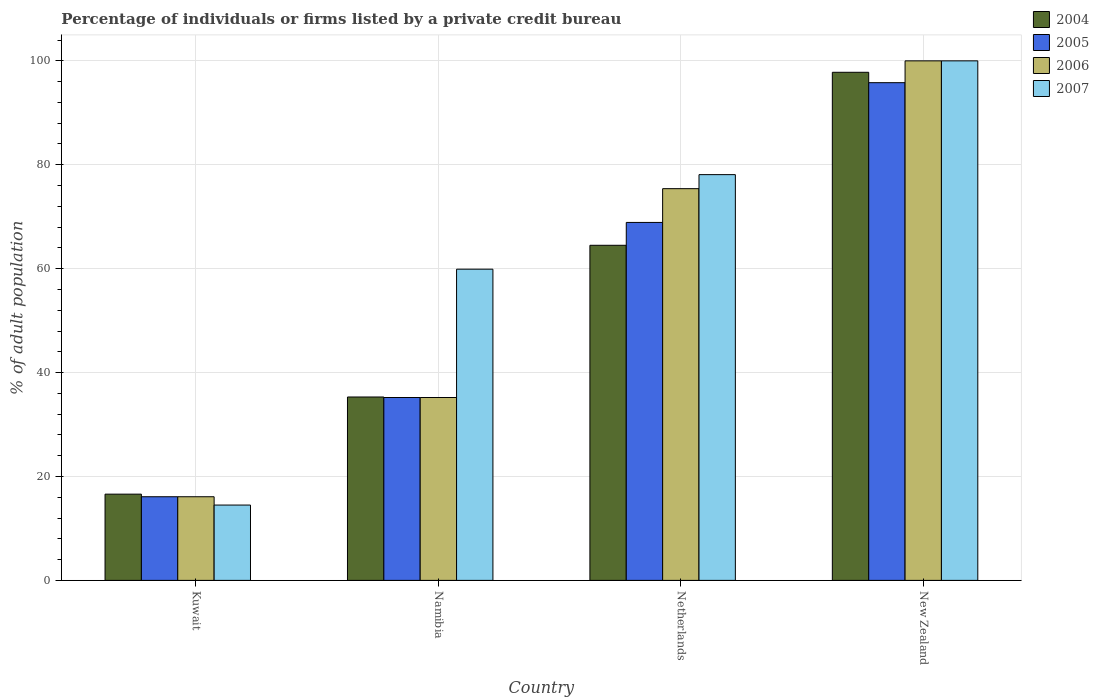How many different coloured bars are there?
Offer a very short reply. 4. How many groups of bars are there?
Provide a succinct answer. 4. How many bars are there on the 2nd tick from the left?
Make the answer very short. 4. How many bars are there on the 2nd tick from the right?
Keep it short and to the point. 4. What is the percentage of population listed by a private credit bureau in 2005 in Namibia?
Make the answer very short. 35.2. In which country was the percentage of population listed by a private credit bureau in 2007 maximum?
Keep it short and to the point. New Zealand. In which country was the percentage of population listed by a private credit bureau in 2006 minimum?
Provide a short and direct response. Kuwait. What is the total percentage of population listed by a private credit bureau in 2004 in the graph?
Give a very brief answer. 214.2. What is the difference between the percentage of population listed by a private credit bureau in 2006 in Kuwait and that in New Zealand?
Provide a succinct answer. -83.9. What is the difference between the percentage of population listed by a private credit bureau in 2005 in Kuwait and the percentage of population listed by a private credit bureau in 2006 in New Zealand?
Provide a succinct answer. -83.9. What is the average percentage of population listed by a private credit bureau in 2004 per country?
Make the answer very short. 53.55. What is the difference between the percentage of population listed by a private credit bureau of/in 2006 and percentage of population listed by a private credit bureau of/in 2004 in Netherlands?
Make the answer very short. 10.9. What is the ratio of the percentage of population listed by a private credit bureau in 2004 in Kuwait to that in New Zealand?
Keep it short and to the point. 0.17. Is the difference between the percentage of population listed by a private credit bureau in 2006 in Kuwait and Namibia greater than the difference between the percentage of population listed by a private credit bureau in 2004 in Kuwait and Namibia?
Offer a very short reply. No. What is the difference between the highest and the second highest percentage of population listed by a private credit bureau in 2005?
Offer a terse response. -33.7. What is the difference between the highest and the lowest percentage of population listed by a private credit bureau in 2004?
Provide a short and direct response. 81.2. In how many countries, is the percentage of population listed by a private credit bureau in 2005 greater than the average percentage of population listed by a private credit bureau in 2005 taken over all countries?
Your answer should be very brief. 2. Is it the case that in every country, the sum of the percentage of population listed by a private credit bureau in 2007 and percentage of population listed by a private credit bureau in 2005 is greater than the sum of percentage of population listed by a private credit bureau in 2004 and percentage of population listed by a private credit bureau in 2006?
Your answer should be compact. No. What does the 4th bar from the left in Kuwait represents?
Keep it short and to the point. 2007. What does the 4th bar from the right in New Zealand represents?
Your answer should be very brief. 2004. How many bars are there?
Offer a terse response. 16. Are all the bars in the graph horizontal?
Ensure brevity in your answer.  No. What is the difference between two consecutive major ticks on the Y-axis?
Keep it short and to the point. 20. Where does the legend appear in the graph?
Offer a very short reply. Top right. How many legend labels are there?
Offer a terse response. 4. What is the title of the graph?
Provide a short and direct response. Percentage of individuals or firms listed by a private credit bureau. What is the label or title of the Y-axis?
Provide a succinct answer. % of adult population. What is the % of adult population of 2005 in Kuwait?
Your answer should be very brief. 16.1. What is the % of adult population in 2006 in Kuwait?
Make the answer very short. 16.1. What is the % of adult population in 2007 in Kuwait?
Provide a succinct answer. 14.5. What is the % of adult population in 2004 in Namibia?
Your answer should be very brief. 35.3. What is the % of adult population in 2005 in Namibia?
Keep it short and to the point. 35.2. What is the % of adult population of 2006 in Namibia?
Provide a short and direct response. 35.2. What is the % of adult population in 2007 in Namibia?
Give a very brief answer. 59.9. What is the % of adult population in 2004 in Netherlands?
Provide a succinct answer. 64.5. What is the % of adult population in 2005 in Netherlands?
Your answer should be very brief. 68.9. What is the % of adult population of 2006 in Netherlands?
Offer a terse response. 75.4. What is the % of adult population of 2007 in Netherlands?
Your response must be concise. 78.1. What is the % of adult population in 2004 in New Zealand?
Provide a succinct answer. 97.8. What is the % of adult population of 2005 in New Zealand?
Provide a succinct answer. 95.8. What is the % of adult population of 2006 in New Zealand?
Your answer should be very brief. 100. Across all countries, what is the maximum % of adult population in 2004?
Provide a short and direct response. 97.8. Across all countries, what is the maximum % of adult population of 2005?
Offer a terse response. 95.8. Across all countries, what is the maximum % of adult population in 2006?
Provide a succinct answer. 100. Across all countries, what is the minimum % of adult population of 2004?
Your answer should be very brief. 16.6. Across all countries, what is the minimum % of adult population of 2006?
Make the answer very short. 16.1. Across all countries, what is the minimum % of adult population of 2007?
Provide a succinct answer. 14.5. What is the total % of adult population in 2004 in the graph?
Keep it short and to the point. 214.2. What is the total % of adult population of 2005 in the graph?
Your answer should be compact. 216. What is the total % of adult population of 2006 in the graph?
Provide a short and direct response. 226.7. What is the total % of adult population of 2007 in the graph?
Your response must be concise. 252.5. What is the difference between the % of adult population of 2004 in Kuwait and that in Namibia?
Provide a short and direct response. -18.7. What is the difference between the % of adult population of 2005 in Kuwait and that in Namibia?
Keep it short and to the point. -19.1. What is the difference between the % of adult population of 2006 in Kuwait and that in Namibia?
Ensure brevity in your answer.  -19.1. What is the difference between the % of adult population in 2007 in Kuwait and that in Namibia?
Your answer should be very brief. -45.4. What is the difference between the % of adult population in 2004 in Kuwait and that in Netherlands?
Your answer should be compact. -47.9. What is the difference between the % of adult population of 2005 in Kuwait and that in Netherlands?
Offer a very short reply. -52.8. What is the difference between the % of adult population of 2006 in Kuwait and that in Netherlands?
Keep it short and to the point. -59.3. What is the difference between the % of adult population of 2007 in Kuwait and that in Netherlands?
Your answer should be very brief. -63.6. What is the difference between the % of adult population of 2004 in Kuwait and that in New Zealand?
Offer a very short reply. -81.2. What is the difference between the % of adult population of 2005 in Kuwait and that in New Zealand?
Offer a terse response. -79.7. What is the difference between the % of adult population of 2006 in Kuwait and that in New Zealand?
Offer a terse response. -83.9. What is the difference between the % of adult population in 2007 in Kuwait and that in New Zealand?
Offer a very short reply. -85.5. What is the difference between the % of adult population in 2004 in Namibia and that in Netherlands?
Ensure brevity in your answer.  -29.2. What is the difference between the % of adult population of 2005 in Namibia and that in Netherlands?
Provide a succinct answer. -33.7. What is the difference between the % of adult population in 2006 in Namibia and that in Netherlands?
Offer a very short reply. -40.2. What is the difference between the % of adult population in 2007 in Namibia and that in Netherlands?
Provide a succinct answer. -18.2. What is the difference between the % of adult population in 2004 in Namibia and that in New Zealand?
Make the answer very short. -62.5. What is the difference between the % of adult population of 2005 in Namibia and that in New Zealand?
Offer a terse response. -60.6. What is the difference between the % of adult population in 2006 in Namibia and that in New Zealand?
Ensure brevity in your answer.  -64.8. What is the difference between the % of adult population of 2007 in Namibia and that in New Zealand?
Make the answer very short. -40.1. What is the difference between the % of adult population of 2004 in Netherlands and that in New Zealand?
Provide a succinct answer. -33.3. What is the difference between the % of adult population of 2005 in Netherlands and that in New Zealand?
Offer a terse response. -26.9. What is the difference between the % of adult population in 2006 in Netherlands and that in New Zealand?
Make the answer very short. -24.6. What is the difference between the % of adult population of 2007 in Netherlands and that in New Zealand?
Your answer should be compact. -21.9. What is the difference between the % of adult population of 2004 in Kuwait and the % of adult population of 2005 in Namibia?
Offer a terse response. -18.6. What is the difference between the % of adult population of 2004 in Kuwait and the % of adult population of 2006 in Namibia?
Your response must be concise. -18.6. What is the difference between the % of adult population in 2004 in Kuwait and the % of adult population in 2007 in Namibia?
Provide a succinct answer. -43.3. What is the difference between the % of adult population in 2005 in Kuwait and the % of adult population in 2006 in Namibia?
Offer a very short reply. -19.1. What is the difference between the % of adult population in 2005 in Kuwait and the % of adult population in 2007 in Namibia?
Offer a very short reply. -43.8. What is the difference between the % of adult population in 2006 in Kuwait and the % of adult population in 2007 in Namibia?
Offer a terse response. -43.8. What is the difference between the % of adult population in 2004 in Kuwait and the % of adult population in 2005 in Netherlands?
Make the answer very short. -52.3. What is the difference between the % of adult population in 2004 in Kuwait and the % of adult population in 2006 in Netherlands?
Ensure brevity in your answer.  -58.8. What is the difference between the % of adult population of 2004 in Kuwait and the % of adult population of 2007 in Netherlands?
Your answer should be very brief. -61.5. What is the difference between the % of adult population of 2005 in Kuwait and the % of adult population of 2006 in Netherlands?
Keep it short and to the point. -59.3. What is the difference between the % of adult population of 2005 in Kuwait and the % of adult population of 2007 in Netherlands?
Make the answer very short. -62. What is the difference between the % of adult population of 2006 in Kuwait and the % of adult population of 2007 in Netherlands?
Your answer should be very brief. -62. What is the difference between the % of adult population of 2004 in Kuwait and the % of adult population of 2005 in New Zealand?
Your answer should be compact. -79.2. What is the difference between the % of adult population in 2004 in Kuwait and the % of adult population in 2006 in New Zealand?
Give a very brief answer. -83.4. What is the difference between the % of adult population of 2004 in Kuwait and the % of adult population of 2007 in New Zealand?
Give a very brief answer. -83.4. What is the difference between the % of adult population of 2005 in Kuwait and the % of adult population of 2006 in New Zealand?
Keep it short and to the point. -83.9. What is the difference between the % of adult population of 2005 in Kuwait and the % of adult population of 2007 in New Zealand?
Ensure brevity in your answer.  -83.9. What is the difference between the % of adult population of 2006 in Kuwait and the % of adult population of 2007 in New Zealand?
Offer a very short reply. -83.9. What is the difference between the % of adult population of 2004 in Namibia and the % of adult population of 2005 in Netherlands?
Make the answer very short. -33.6. What is the difference between the % of adult population in 2004 in Namibia and the % of adult population in 2006 in Netherlands?
Your answer should be very brief. -40.1. What is the difference between the % of adult population of 2004 in Namibia and the % of adult population of 2007 in Netherlands?
Keep it short and to the point. -42.8. What is the difference between the % of adult population of 2005 in Namibia and the % of adult population of 2006 in Netherlands?
Ensure brevity in your answer.  -40.2. What is the difference between the % of adult population in 2005 in Namibia and the % of adult population in 2007 in Netherlands?
Keep it short and to the point. -42.9. What is the difference between the % of adult population of 2006 in Namibia and the % of adult population of 2007 in Netherlands?
Provide a short and direct response. -42.9. What is the difference between the % of adult population in 2004 in Namibia and the % of adult population in 2005 in New Zealand?
Your response must be concise. -60.5. What is the difference between the % of adult population of 2004 in Namibia and the % of adult population of 2006 in New Zealand?
Ensure brevity in your answer.  -64.7. What is the difference between the % of adult population in 2004 in Namibia and the % of adult population in 2007 in New Zealand?
Give a very brief answer. -64.7. What is the difference between the % of adult population in 2005 in Namibia and the % of adult population in 2006 in New Zealand?
Your response must be concise. -64.8. What is the difference between the % of adult population in 2005 in Namibia and the % of adult population in 2007 in New Zealand?
Give a very brief answer. -64.8. What is the difference between the % of adult population in 2006 in Namibia and the % of adult population in 2007 in New Zealand?
Provide a succinct answer. -64.8. What is the difference between the % of adult population of 2004 in Netherlands and the % of adult population of 2005 in New Zealand?
Offer a terse response. -31.3. What is the difference between the % of adult population of 2004 in Netherlands and the % of adult population of 2006 in New Zealand?
Offer a terse response. -35.5. What is the difference between the % of adult population in 2004 in Netherlands and the % of adult population in 2007 in New Zealand?
Offer a very short reply. -35.5. What is the difference between the % of adult population of 2005 in Netherlands and the % of adult population of 2006 in New Zealand?
Give a very brief answer. -31.1. What is the difference between the % of adult population of 2005 in Netherlands and the % of adult population of 2007 in New Zealand?
Make the answer very short. -31.1. What is the difference between the % of adult population of 2006 in Netherlands and the % of adult population of 2007 in New Zealand?
Your answer should be very brief. -24.6. What is the average % of adult population in 2004 per country?
Offer a very short reply. 53.55. What is the average % of adult population in 2006 per country?
Make the answer very short. 56.67. What is the average % of adult population of 2007 per country?
Your answer should be compact. 63.12. What is the difference between the % of adult population of 2004 and % of adult population of 2007 in Kuwait?
Make the answer very short. 2.1. What is the difference between the % of adult population of 2005 and % of adult population of 2006 in Kuwait?
Keep it short and to the point. 0. What is the difference between the % of adult population of 2005 and % of adult population of 2007 in Kuwait?
Give a very brief answer. 1.6. What is the difference between the % of adult population in 2004 and % of adult population in 2007 in Namibia?
Keep it short and to the point. -24.6. What is the difference between the % of adult population of 2005 and % of adult population of 2007 in Namibia?
Offer a very short reply. -24.7. What is the difference between the % of adult population of 2006 and % of adult population of 2007 in Namibia?
Provide a succinct answer. -24.7. What is the difference between the % of adult population in 2004 and % of adult population in 2005 in Netherlands?
Keep it short and to the point. -4.4. What is the difference between the % of adult population of 2004 and % of adult population of 2006 in Netherlands?
Offer a very short reply. -10.9. What is the difference between the % of adult population of 2004 and % of adult population of 2007 in Netherlands?
Keep it short and to the point. -13.6. What is the difference between the % of adult population in 2004 and % of adult population in 2006 in New Zealand?
Keep it short and to the point. -2.2. What is the difference between the % of adult population in 2004 and % of adult population in 2007 in New Zealand?
Provide a succinct answer. -2.2. What is the difference between the % of adult population of 2005 and % of adult population of 2007 in New Zealand?
Provide a succinct answer. -4.2. What is the ratio of the % of adult population in 2004 in Kuwait to that in Namibia?
Keep it short and to the point. 0.47. What is the ratio of the % of adult population of 2005 in Kuwait to that in Namibia?
Your answer should be compact. 0.46. What is the ratio of the % of adult population of 2006 in Kuwait to that in Namibia?
Give a very brief answer. 0.46. What is the ratio of the % of adult population in 2007 in Kuwait to that in Namibia?
Your answer should be very brief. 0.24. What is the ratio of the % of adult population in 2004 in Kuwait to that in Netherlands?
Provide a short and direct response. 0.26. What is the ratio of the % of adult population in 2005 in Kuwait to that in Netherlands?
Your response must be concise. 0.23. What is the ratio of the % of adult population of 2006 in Kuwait to that in Netherlands?
Make the answer very short. 0.21. What is the ratio of the % of adult population in 2007 in Kuwait to that in Netherlands?
Your answer should be compact. 0.19. What is the ratio of the % of adult population in 2004 in Kuwait to that in New Zealand?
Offer a terse response. 0.17. What is the ratio of the % of adult population of 2005 in Kuwait to that in New Zealand?
Your answer should be very brief. 0.17. What is the ratio of the % of adult population of 2006 in Kuwait to that in New Zealand?
Your response must be concise. 0.16. What is the ratio of the % of adult population in 2007 in Kuwait to that in New Zealand?
Give a very brief answer. 0.14. What is the ratio of the % of adult population in 2004 in Namibia to that in Netherlands?
Provide a succinct answer. 0.55. What is the ratio of the % of adult population in 2005 in Namibia to that in Netherlands?
Your answer should be compact. 0.51. What is the ratio of the % of adult population of 2006 in Namibia to that in Netherlands?
Keep it short and to the point. 0.47. What is the ratio of the % of adult population in 2007 in Namibia to that in Netherlands?
Provide a short and direct response. 0.77. What is the ratio of the % of adult population in 2004 in Namibia to that in New Zealand?
Offer a very short reply. 0.36. What is the ratio of the % of adult population of 2005 in Namibia to that in New Zealand?
Offer a terse response. 0.37. What is the ratio of the % of adult population in 2006 in Namibia to that in New Zealand?
Offer a terse response. 0.35. What is the ratio of the % of adult population in 2007 in Namibia to that in New Zealand?
Make the answer very short. 0.6. What is the ratio of the % of adult population of 2004 in Netherlands to that in New Zealand?
Offer a terse response. 0.66. What is the ratio of the % of adult population in 2005 in Netherlands to that in New Zealand?
Your answer should be compact. 0.72. What is the ratio of the % of adult population of 2006 in Netherlands to that in New Zealand?
Give a very brief answer. 0.75. What is the ratio of the % of adult population of 2007 in Netherlands to that in New Zealand?
Make the answer very short. 0.78. What is the difference between the highest and the second highest % of adult population of 2004?
Ensure brevity in your answer.  33.3. What is the difference between the highest and the second highest % of adult population in 2005?
Your answer should be very brief. 26.9. What is the difference between the highest and the second highest % of adult population of 2006?
Ensure brevity in your answer.  24.6. What is the difference between the highest and the second highest % of adult population of 2007?
Your answer should be compact. 21.9. What is the difference between the highest and the lowest % of adult population in 2004?
Your answer should be very brief. 81.2. What is the difference between the highest and the lowest % of adult population of 2005?
Keep it short and to the point. 79.7. What is the difference between the highest and the lowest % of adult population in 2006?
Offer a terse response. 83.9. What is the difference between the highest and the lowest % of adult population of 2007?
Your response must be concise. 85.5. 